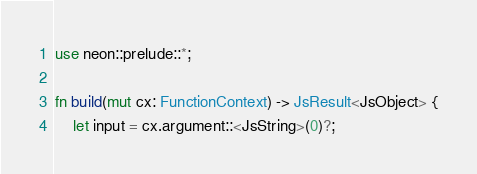Convert code to text. <code><loc_0><loc_0><loc_500><loc_500><_Rust_>use neon::prelude::*;

fn build(mut cx: FunctionContext) -> JsResult<JsObject> {
	let input = cx.argument::<JsString>(0)?;</code> 